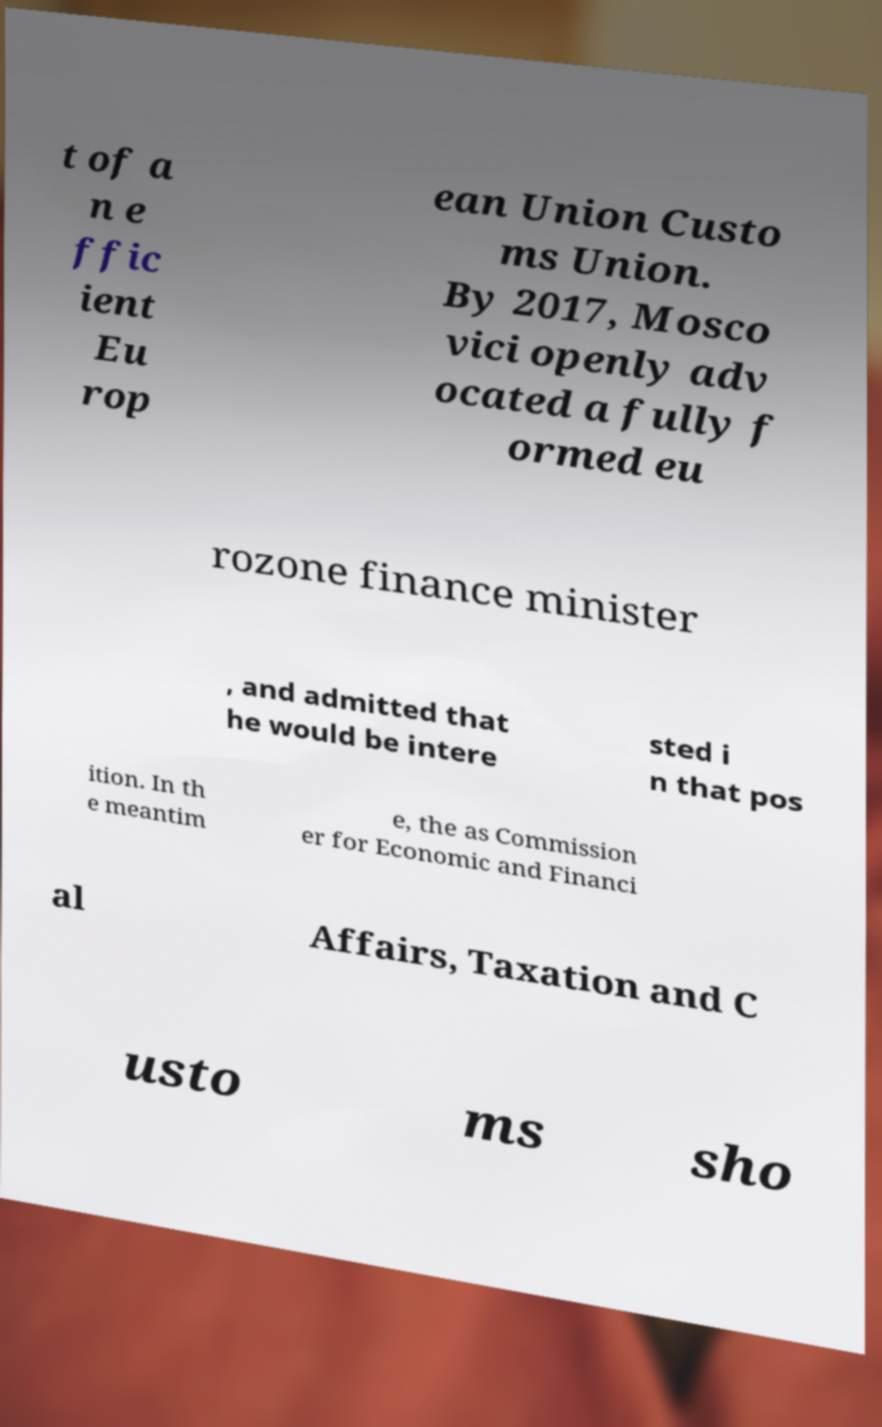There's text embedded in this image that I need extracted. Can you transcribe it verbatim? t of a n e ffic ient Eu rop ean Union Custo ms Union. By 2017, Mosco vici openly adv ocated a fully f ormed eu rozone finance minister , and admitted that he would be intere sted i n that pos ition. In th e meantim e, the as Commission er for Economic and Financi al Affairs, Taxation and C usto ms sho 